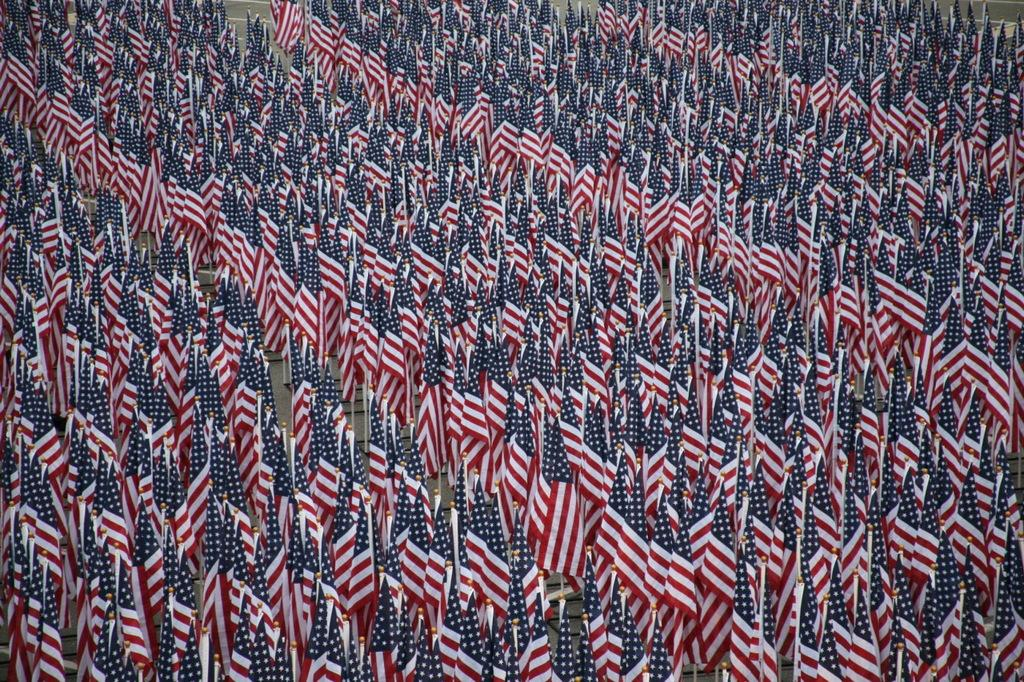What objects are present in the image that are related to national symbols? There are flags in the image. How are the flags positioned in the image? The flags are attached to poles. Where are the flags and poles located in the image? The flags and poles are on the land. Is there a volcano erupting in the background of the image? There is no volcano present in the image. Can you see a visitor walking around the flags in the image? There is no visitor present in the image. 